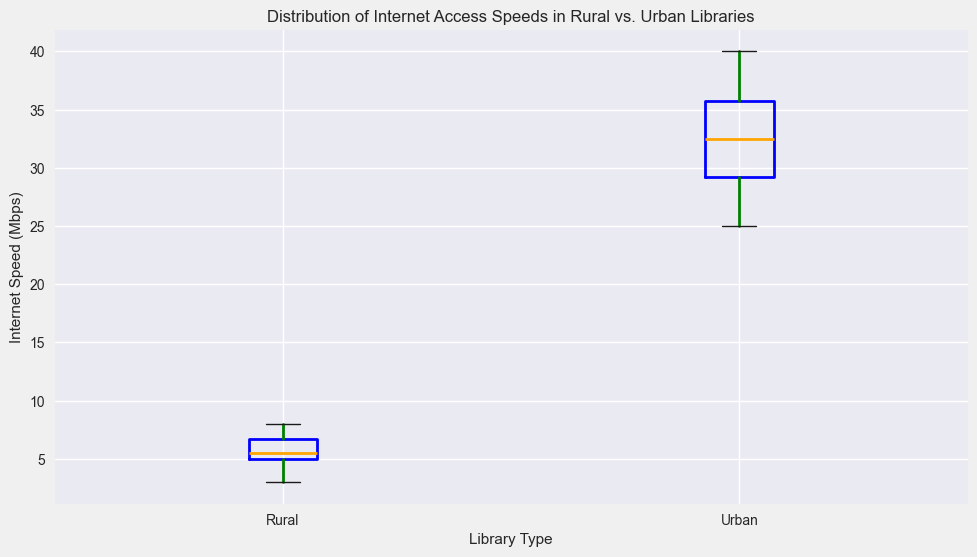What's the median internet speed in rural libraries? To find the median for the rural libraries, we first list out the internet speeds: 3, 4, 5, 5, 5, 6, 6, 7, 7, 8. The median is the middle value, which is the 5th and 6th values averaged out: (5 + 6)/2 = 5.5
Answer: 5.5 Mbps What's the median internet speed in urban libraries? To find the median for the urban libraries, we list the speeds: 25, 28, 29, 30, 32, 33, 35, 36, 37, 40. The middle values are the 5th and 6th values averaged: (32 + 33)/2 = 32.5
Answer: 32.5 Mbps Which library type has the higher median internet speed? Comparing the medians from both rural and urban libraries, rural is 5.5 Mbps and urban is 32.5 Mbps. Urban libraries have the higher median internet speed.
Answer: Urban libraries What is the interquartile range (IQR) of internet speeds in rural libraries? To find the IQR, first identify the 1st quartile (Q1) and 3rd quartile (Q3). For rural libraries, Q1 (25th percentile) is between 4 and 5, and Q3 (75th percentile) is between 6 and 7, so Q1 is 4.5 and Q3 is 6.5. IQR = Q3 - Q1, so IQR = 6.5 - 4.5 = 2
Answer: 2 Mbps What is the interquartile range (IQR) of internet speeds in urban libraries? For urban libraries, Q1 (25th percentile) is between 28 and 29, and Q3 (75th percentile) is between 35 and 36, so Q1 is 28.5 and Q3 is 35.5. IQR = Q3 - Q1, so IQR = 35.5 - 28.5 = 7
Answer: 7 Mbps How do the ranges of internet speeds compare between rural and urban libraries? The range is the difference between the highest and lowest values. For rural libraries, the range is 8 - 3 = 5 Mbps. For urban libraries, the range is 40 - 25 = 15 Mbps. Urban libraries have a larger range of internet speeds.
Answer: Urban libraries have a larger range What color represents the flier points (outliers) in the plot? The flier points (outliers) in the box plot are marked with the color red.
Answer: Red What does the height of the box represent in a box plot? The height of the box in a box plot represents the interquartile range (IQR), which is the middle 50% of the data between the 1st and 3rd quartiles (Q1 and Q3).
Answer: Interquartile range (IQR) What is the median value visually indicated by in the box plot? In a box plot, the median value is visually indicated by the line inside the box, colored in orange in this plot.
Answer: Orange line 